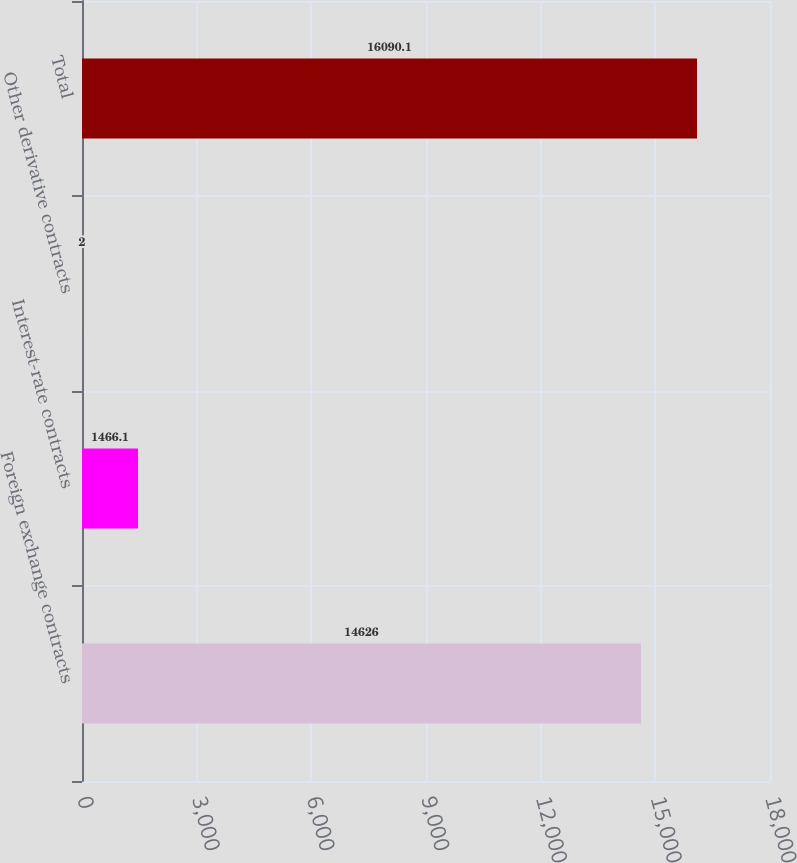Convert chart to OTSL. <chart><loc_0><loc_0><loc_500><loc_500><bar_chart><fcel>Foreign exchange contracts<fcel>Interest-rate contracts<fcel>Other derivative contracts<fcel>Total<nl><fcel>14626<fcel>1466.1<fcel>2<fcel>16090.1<nl></chart> 